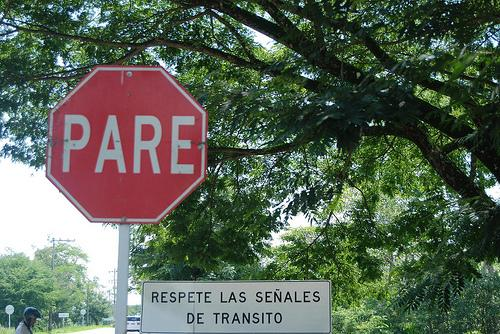What are the elements present in the background of the photograph? In the background there are trees covered in green leaves, a sky, and street signs on the side of the road. Describe the type of helmet a person in the photo is wearing. The person is wearing a dark, likely black, motorcycle helmet. In the image, what is the color and material of the sign post attached to the red sign? Grey metal sign post is attached to the red sign. Identify and describe the activity happening involving a man in the image. A man is walking across the road, wearing a helmet. Can you tell me the main color and shape of the sign on the image? The main sign is red and has an octagonal shape. Identify what is written on the red sign and in what color are the letters. The red sign has the word "pare" written in white capital letters. What language can be identified on the signs in the image? The signs are in Spanish language. How many signs have white background with black writings in the image? There is one white sign with black lettering in the image. What type of vehicle is seen driving on the road in the image? A white car or automobile is driving on the road. What is the sentiment expressed by the image - positive, negative or neutral? The image has a neutral sentiment. Evaluate the quality of the image. The image is clear with visible and identifiable objects. What language are the signs written in? The signs are written in Spanish. Detect the color of the sign post. The sign post is gray and metal. Is the person wearing a motorcycle helmet? Yes, the person is wearing a black motorcycle helmet. Detect any unusual elements in the image. There are no unusual elements in the image. Identify the white object next to the red sign. The white object is a rectangular sign with black writing. Find the color of the helmet that the person is wearing. The person is wearing a dark helmet. Which statement is true about the red sign on the pole: it is square or it is octagonal? The red sign is octagonal. What covers the trees in the image? The trees are covered in green leaves. Analyze the interaction between the red sign and the pole. The red sign is attached to the pole with a metal bolt, and they are secured together. Explain how the stop sign is secured to the pole. The stop sign is secured to the pole with a metal bolt. Identify the object above the white sign. The object above the white sign is a red octagonal stop sign. Determine the sentiment of the image. The sentiment of the image is neutral. How does the foliage on the trees appear in the image? The foliage on the trees appears green and lush. Read the text on the red sign. The red sign says "pare." Which statement is true about the white automobile: it has red tail lights or it has blue headlights? The white automobile has red tail lights. Describe the red sign in the image. The red sign is an octagon with white writing and a white line around the edge. It is attached to a pole. What type of vehicle is on the road? There is a white car driving on the road. Describe the shape and color of the white sign with black lettering. The sign is white, rectangular, and has black lettering. 